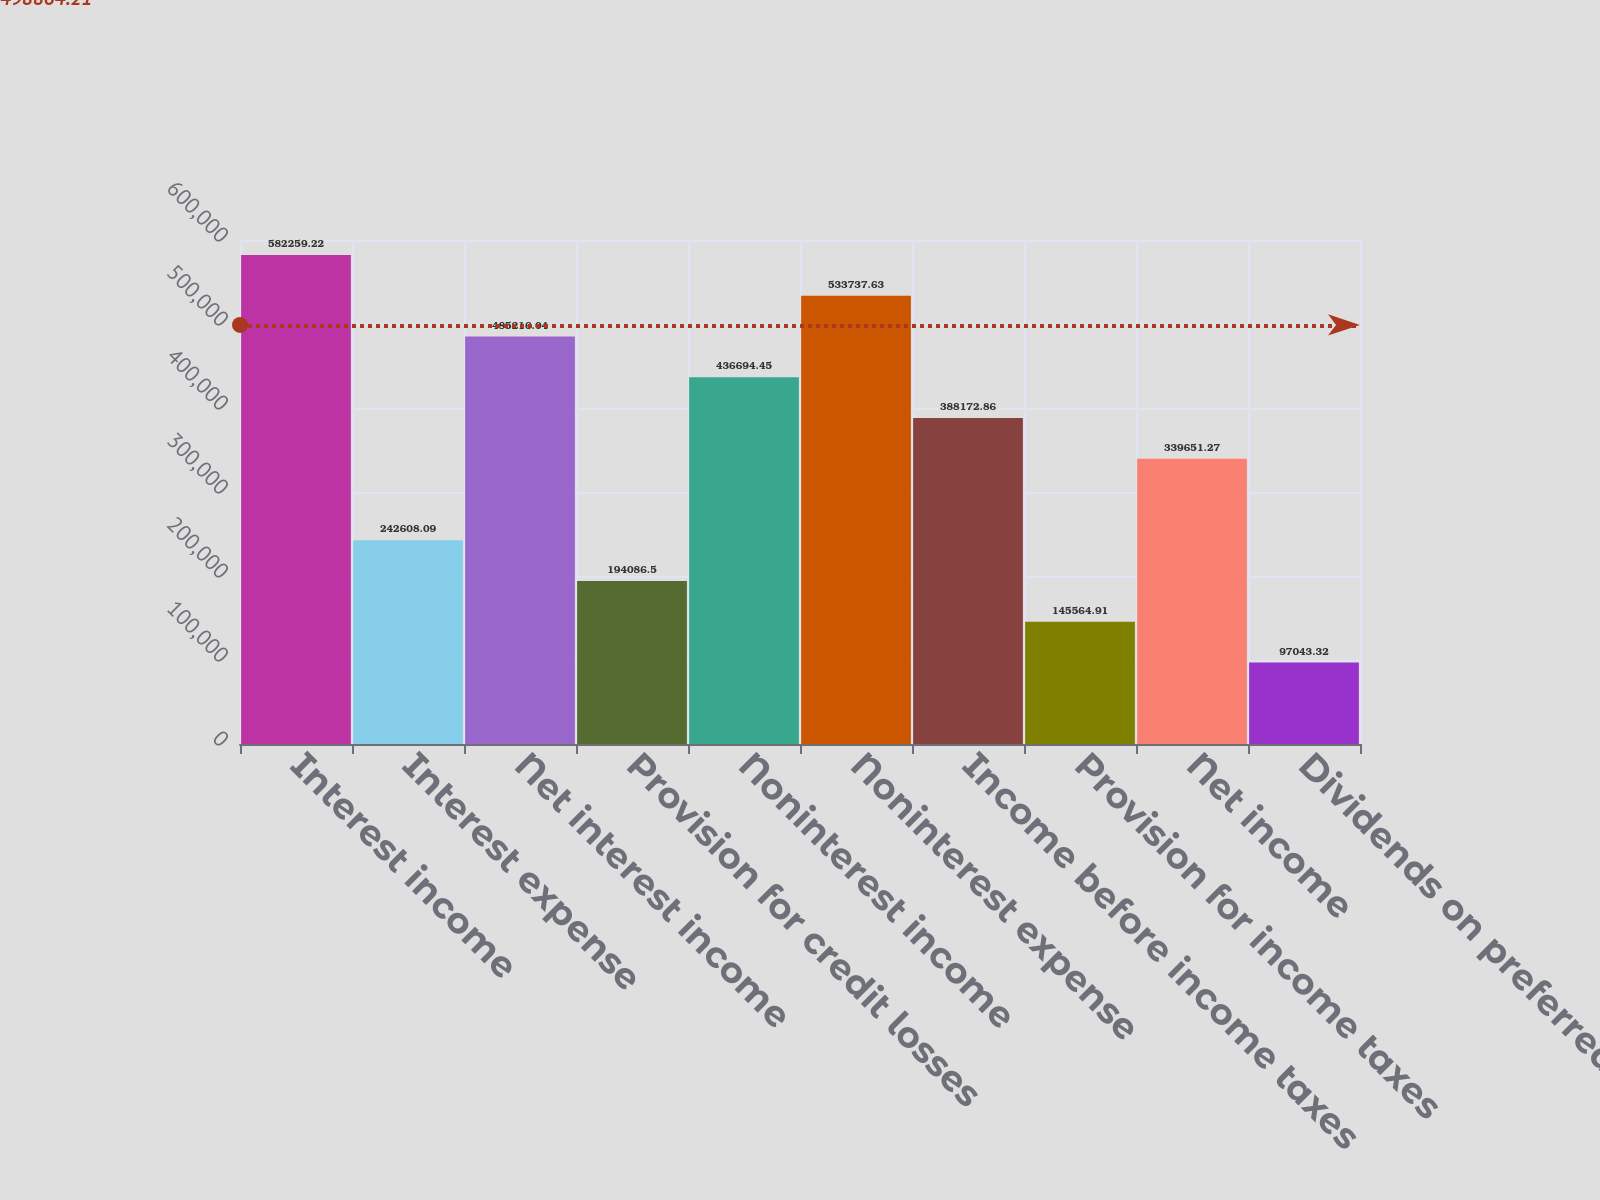Convert chart to OTSL. <chart><loc_0><loc_0><loc_500><loc_500><bar_chart><fcel>Interest income<fcel>Interest expense<fcel>Net interest income<fcel>Provision for credit losses<fcel>Noninterest income<fcel>Noninterest expense<fcel>Income before income taxes<fcel>Provision for income taxes<fcel>Net income<fcel>Dividends on preferred shares<nl><fcel>582259<fcel>242608<fcel>485216<fcel>194086<fcel>436694<fcel>533738<fcel>388173<fcel>145565<fcel>339651<fcel>97043.3<nl></chart> 